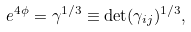<formula> <loc_0><loc_0><loc_500><loc_500>e ^ { 4 \phi } = \gamma ^ { 1 / 3 } \equiv \det ( \gamma _ { i j } ) ^ { 1 / 3 } ,</formula> 